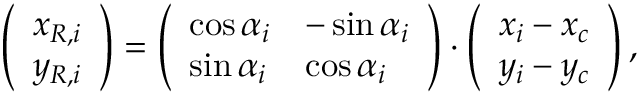Convert formula to latex. <formula><loc_0><loc_0><loc_500><loc_500>\left ( \begin{array} { l } { x _ { R , i } } \\ { y _ { R , i } } \end{array} \right ) = \left ( \begin{array} { l l } { \cos { \alpha _ { i } } } & { - \sin { \alpha _ { i } } } \\ { \sin { \alpha _ { i } } } & { \cos { \alpha _ { i } } } \end{array} \right ) \cdot \left ( \begin{array} { l } { x _ { i } - x _ { c } } \\ { y _ { i } - y _ { c } } \end{array} \right ) ,</formula> 